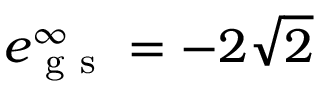<formula> <loc_0><loc_0><loc_500><loc_500>e _ { g s } ^ { \infty } = - 2 \sqrt { 2 }</formula> 